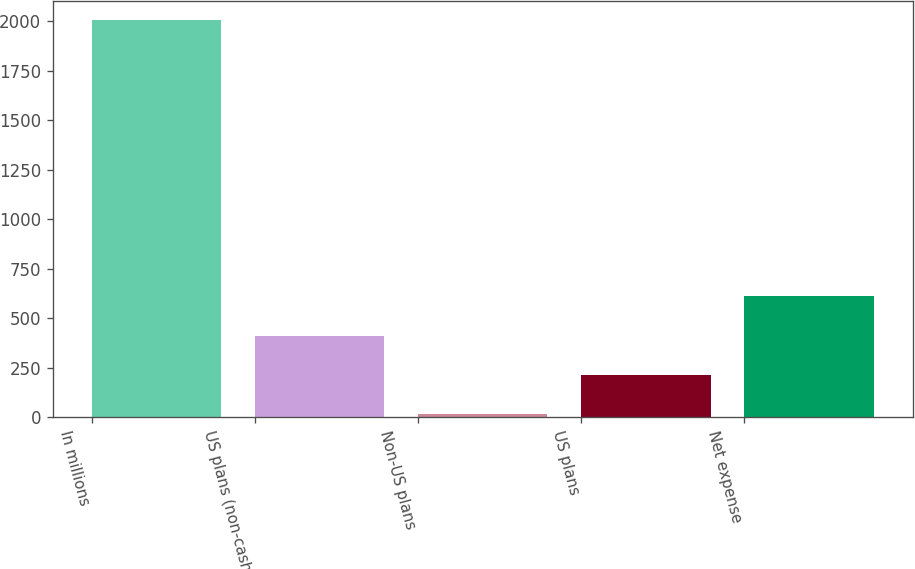Convert chart. <chart><loc_0><loc_0><loc_500><loc_500><bar_chart><fcel>In millions<fcel>US plans (non-cash)<fcel>Non-US plans<fcel>US plans<fcel>Net expense<nl><fcel>2004<fcel>412.8<fcel>15<fcel>213.9<fcel>611.7<nl></chart> 